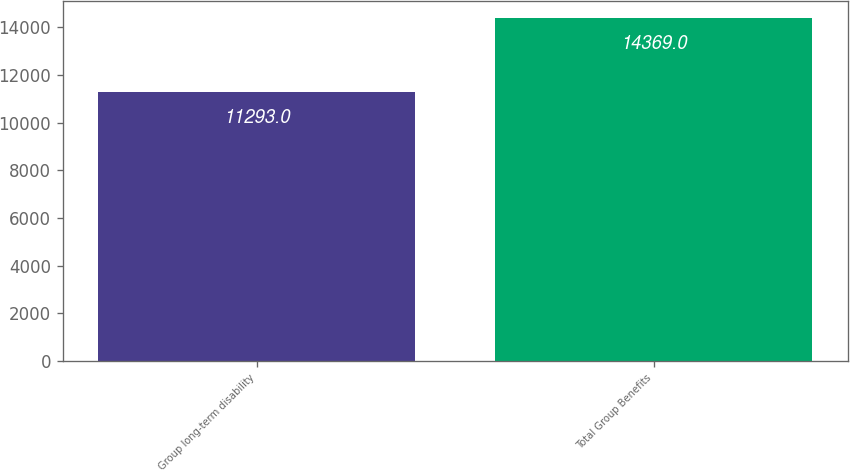Convert chart. <chart><loc_0><loc_0><loc_500><loc_500><bar_chart><fcel>Group long-term disability<fcel>Total Group Benefits<nl><fcel>11293<fcel>14369<nl></chart> 